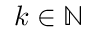<formula> <loc_0><loc_0><loc_500><loc_500>k \in \mathbb { N }</formula> 